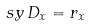Convert formula to latex. <formula><loc_0><loc_0><loc_500><loc_500>\ s y \, D _ { x } = r _ { x }</formula> 